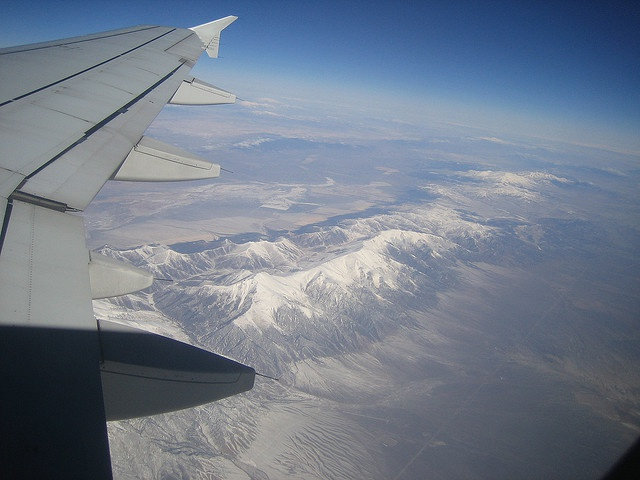Describe the objects in this image and their specific colors. I can see a airplane in blue, darkgray, black, and gray tones in this image. 